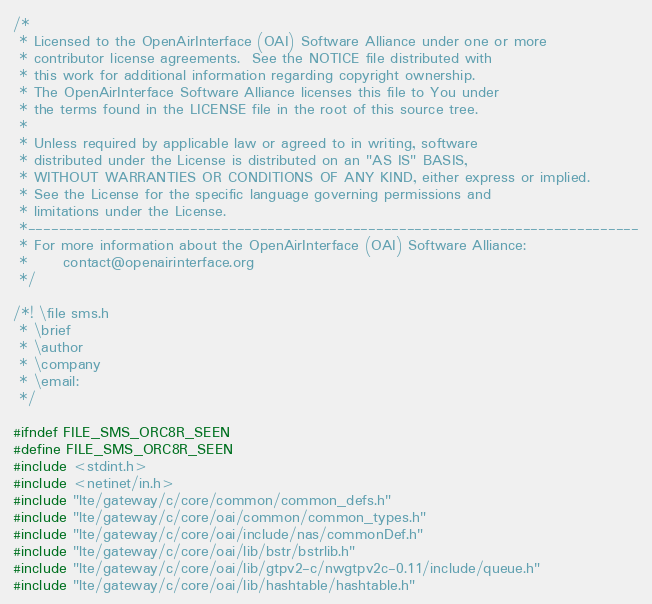Convert code to text. <code><loc_0><loc_0><loc_500><loc_500><_C_>/*
 * Licensed to the OpenAirInterface (OAI) Software Alliance under one or more
 * contributor license agreements.  See the NOTICE file distributed with
 * this work for additional information regarding copyright ownership.
 * The OpenAirInterface Software Alliance licenses this file to You under
 * the terms found in the LICENSE file in the root of this source tree.
 *
 * Unless required by applicable law or agreed to in writing, software
 * distributed under the License is distributed on an "AS IS" BASIS,
 * WITHOUT WARRANTIES OR CONDITIONS OF ANY KIND, either express or implied.
 * See the License for the specific language governing permissions and
 * limitations under the License.
 *-------------------------------------------------------------------------------
 * For more information about the OpenAirInterface (OAI) Software Alliance:
 *      contact@openairinterface.org
 */

/*! \file sms.h
 * \brief
 * \author
 * \company
 * \email:
 */

#ifndef FILE_SMS_ORC8R_SEEN
#define FILE_SMS_ORC8R_SEEN
#include <stdint.h>
#include <netinet/in.h>
#include "lte/gateway/c/core/common/common_defs.h"
#include "lte/gateway/c/core/oai/common/common_types.h"
#include "lte/gateway/c/core/oai/include/nas/commonDef.h"
#include "lte/gateway/c/core/oai/lib/bstr/bstrlib.h"
#include "lte/gateway/c/core/oai/lib/gtpv2-c/nwgtpv2c-0.11/include/queue.h"
#include "lte/gateway/c/core/oai/lib/hashtable/hashtable.h"
</code> 